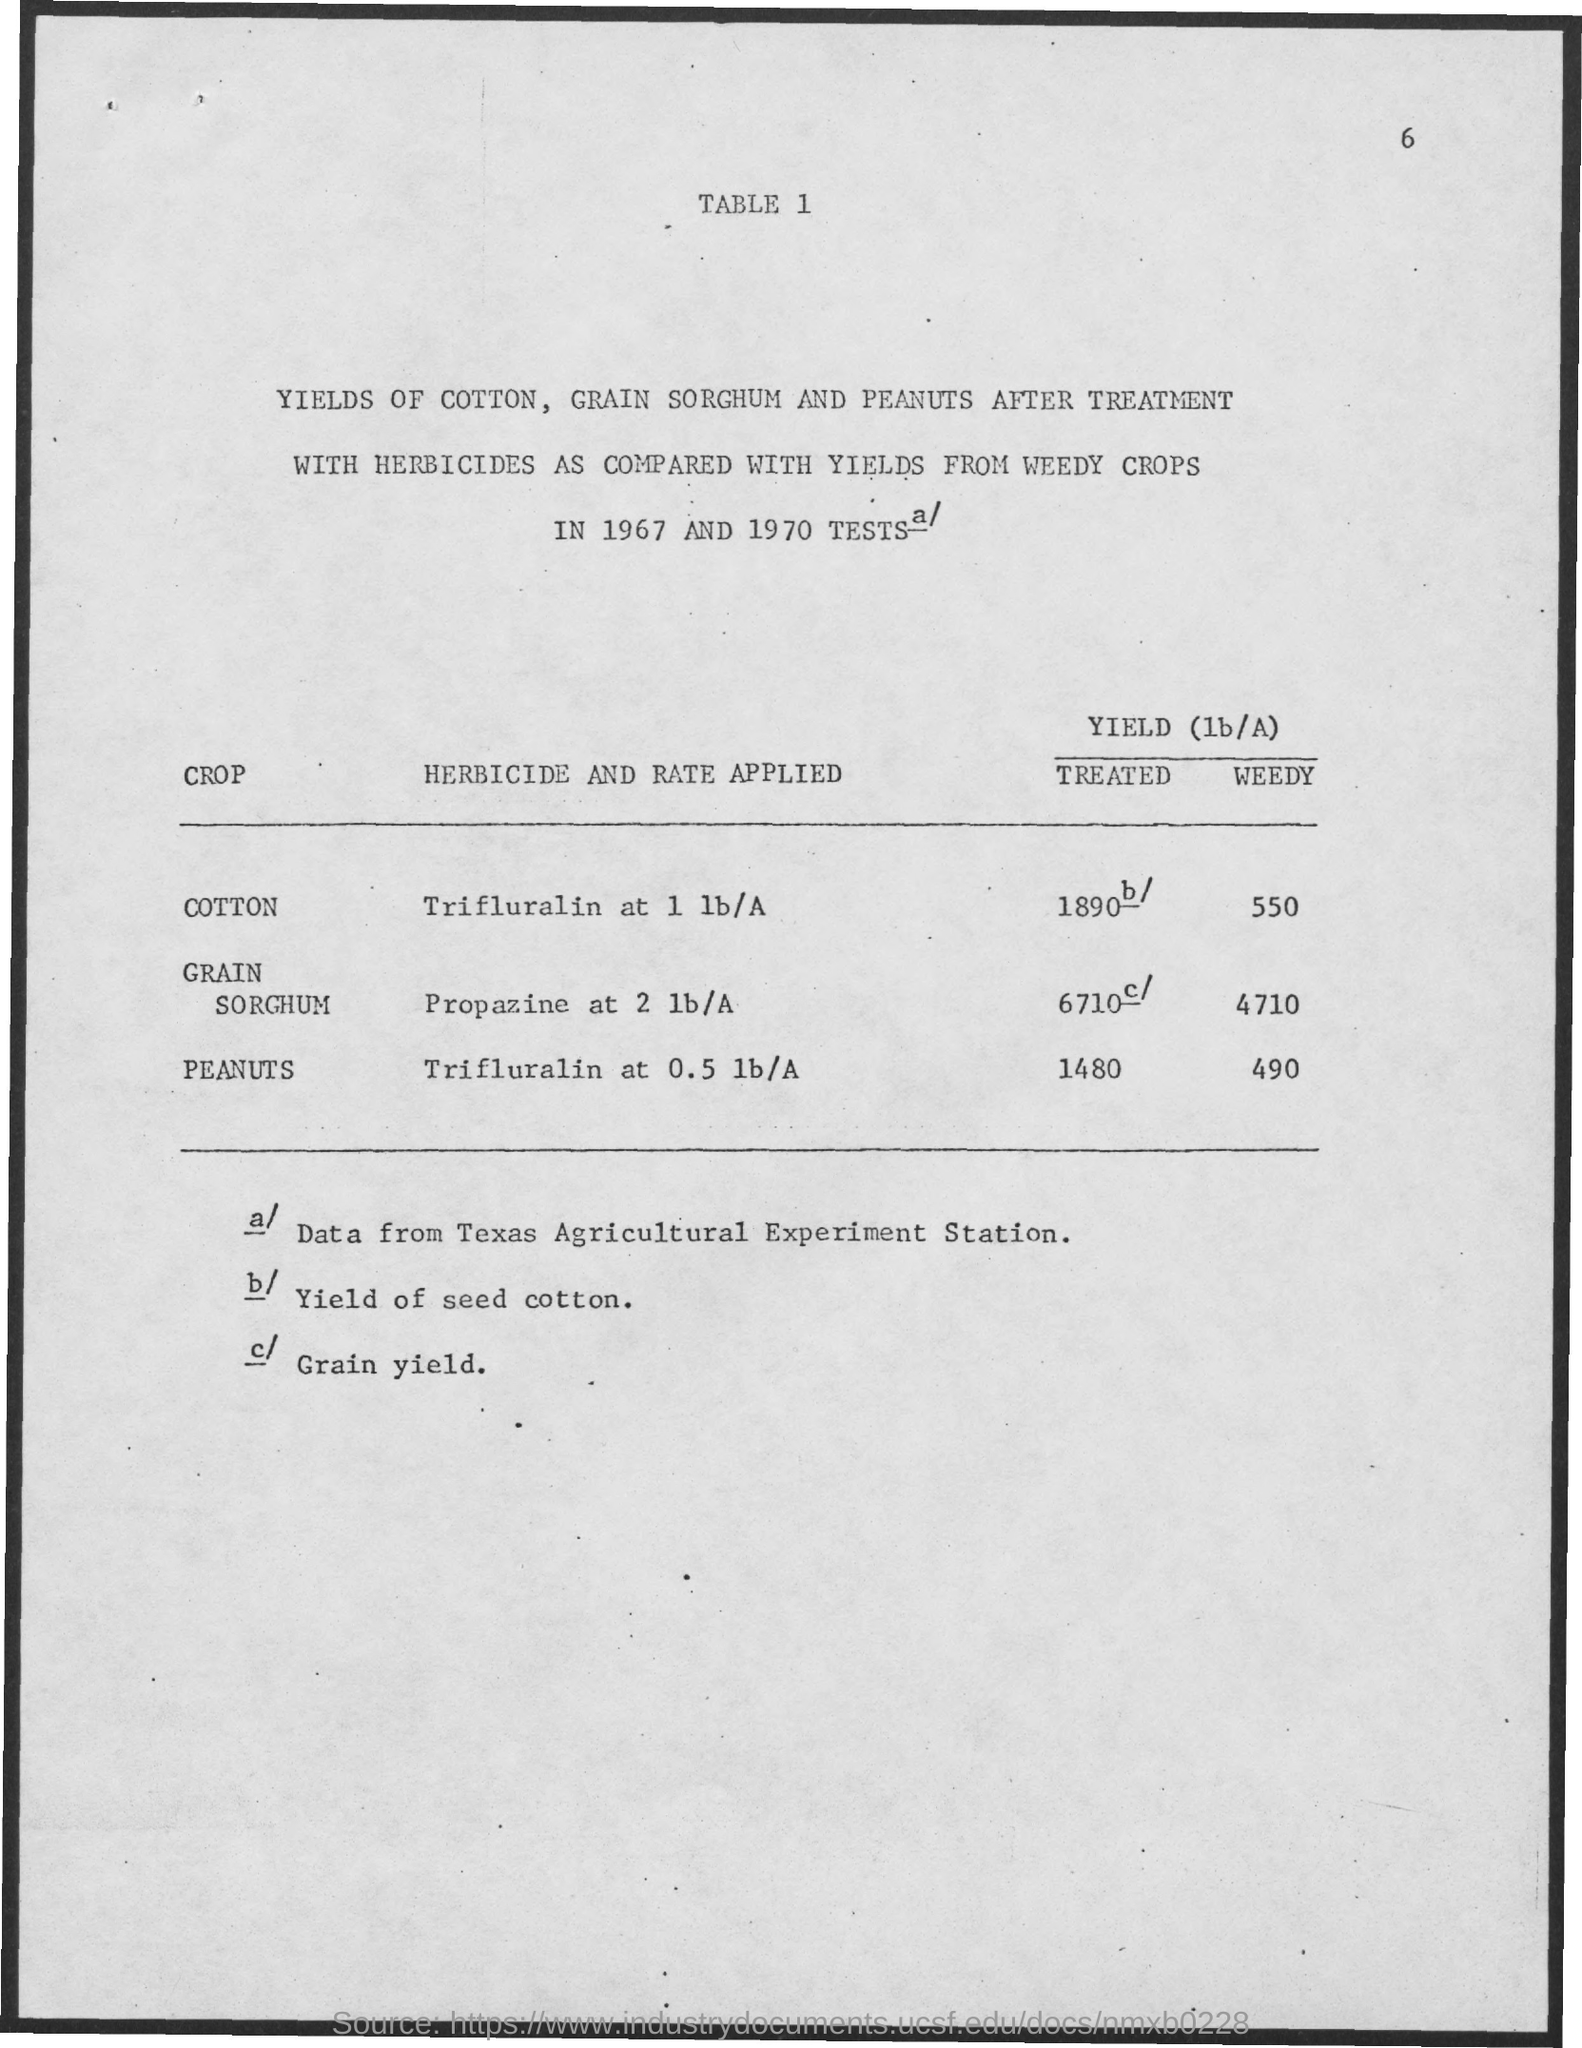Identify some key points in this picture. The herbicide and rate applied to peanuts is trifluralin at 0.5 lb/A. The herbicide propazine was applied at a rate of 2 pounds per acre to the grain sorghum crop. The herbicide trifluralin was applied at a rate of 1 pound per acre to cotton. The tests were held in both 1967 and 1970. 